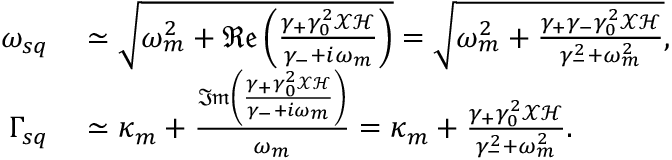Convert formula to latex. <formula><loc_0><loc_0><loc_500><loc_500>\begin{array} { r l } { \omega _ { s q } } & \simeq \sqrt { \omega _ { m } ^ { 2 } + \mathfrak { R e } \left ( \frac { \gamma _ { + } \gamma _ { 0 } ^ { 2 } \mathcal { X } \mathcal { H } } { \gamma _ { - } + i \omega _ { m } } \right ) } = \sqrt { \omega _ { m } ^ { 2 } + \frac { \gamma _ { + } \gamma _ { - } \gamma _ { 0 } ^ { 2 } \mathcal { X } \mathcal { H } } { \gamma _ { - } ^ { 2 } + \omega _ { m } ^ { 2 } } } , } \\ { \Gamma _ { s q } } & \simeq \kappa _ { m } + \frac { \mathfrak { I m } \left ( \frac { \gamma _ { + } \gamma _ { 0 } ^ { 2 } \mathcal { X } \mathcal { H } } { \gamma _ { - } + i \omega _ { m } } \right ) } { \omega _ { m } } = \kappa _ { m } + \frac { \gamma _ { + } \gamma _ { 0 } ^ { 2 } \mathcal { X } \mathcal { H } } { \gamma _ { - } ^ { 2 } + \omega _ { m } ^ { 2 } } . } \end{array}</formula> 